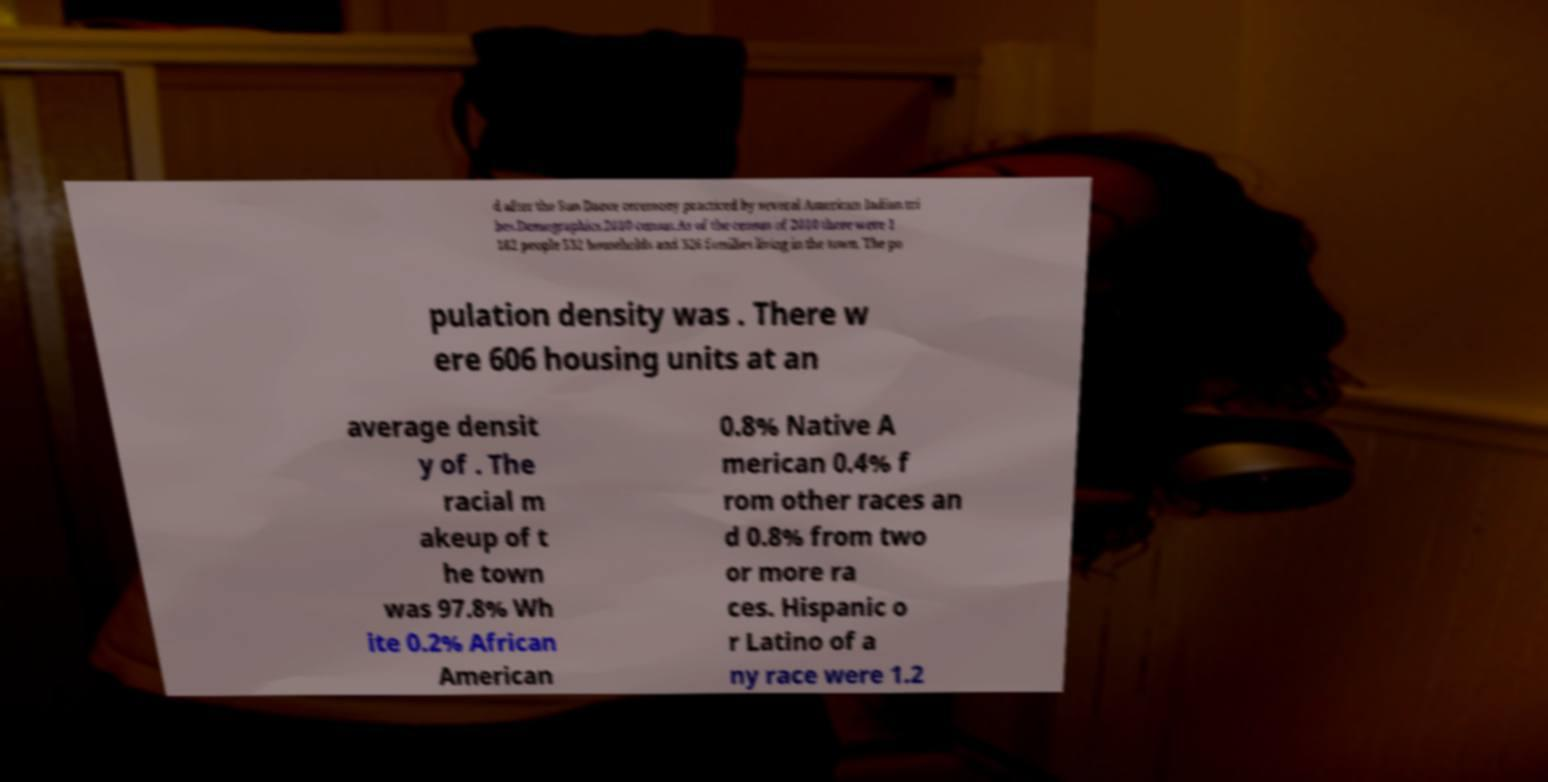Could you extract and type out the text from this image? d after the Sun Dance ceremony practiced by several American Indian tri bes.Demographics.2010 census.As of the census of 2010 there were 1 182 people 532 households and 326 families living in the town. The po pulation density was . There w ere 606 housing units at an average densit y of . The racial m akeup of t he town was 97.8% Wh ite 0.2% African American 0.8% Native A merican 0.4% f rom other races an d 0.8% from two or more ra ces. Hispanic o r Latino of a ny race were 1.2 